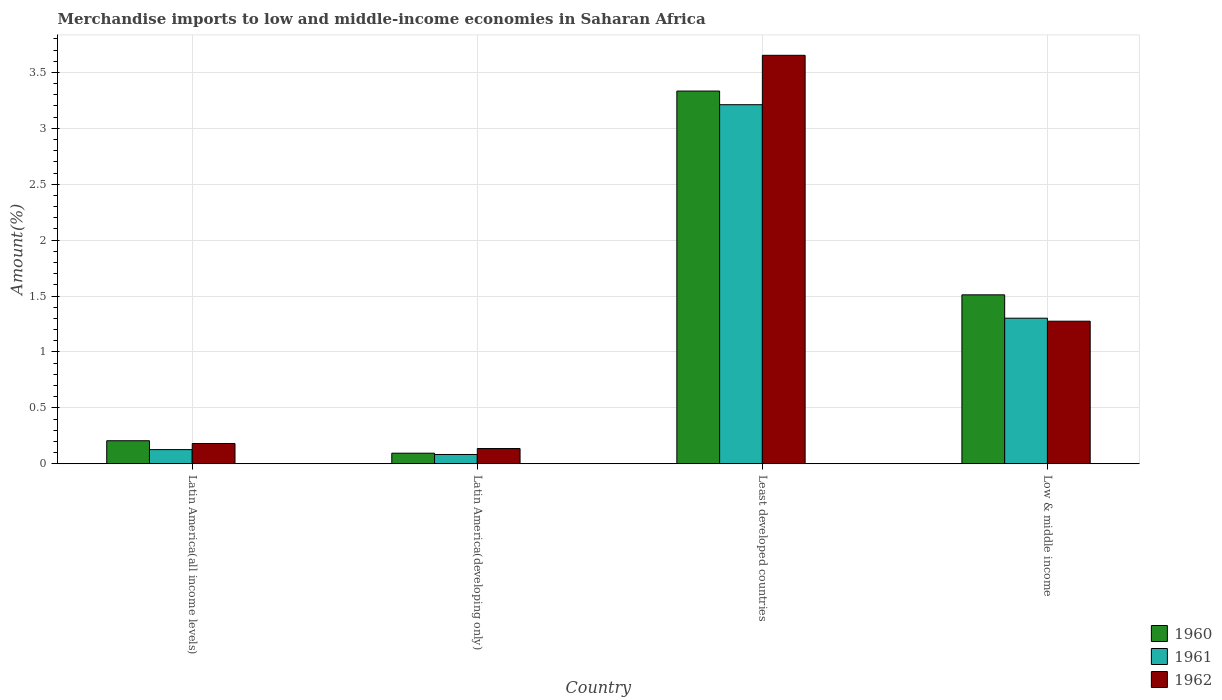How many different coloured bars are there?
Make the answer very short. 3. Are the number of bars per tick equal to the number of legend labels?
Offer a terse response. Yes. Are the number of bars on each tick of the X-axis equal?
Your response must be concise. Yes. How many bars are there on the 3rd tick from the right?
Offer a terse response. 3. What is the label of the 4th group of bars from the left?
Your answer should be compact. Low & middle income. In how many cases, is the number of bars for a given country not equal to the number of legend labels?
Provide a succinct answer. 0. What is the percentage of amount earned from merchandise imports in 1961 in Latin America(developing only)?
Keep it short and to the point. 0.08. Across all countries, what is the maximum percentage of amount earned from merchandise imports in 1961?
Your answer should be compact. 3.21. Across all countries, what is the minimum percentage of amount earned from merchandise imports in 1960?
Offer a very short reply. 0.09. In which country was the percentage of amount earned from merchandise imports in 1960 maximum?
Provide a succinct answer. Least developed countries. In which country was the percentage of amount earned from merchandise imports in 1962 minimum?
Your answer should be compact. Latin America(developing only). What is the total percentage of amount earned from merchandise imports in 1962 in the graph?
Give a very brief answer. 5.24. What is the difference between the percentage of amount earned from merchandise imports in 1961 in Latin America(all income levels) and that in Low & middle income?
Ensure brevity in your answer.  -1.18. What is the difference between the percentage of amount earned from merchandise imports in 1962 in Least developed countries and the percentage of amount earned from merchandise imports in 1961 in Latin America(developing only)?
Your response must be concise. 3.57. What is the average percentage of amount earned from merchandise imports in 1962 per country?
Your answer should be compact. 1.31. What is the difference between the percentage of amount earned from merchandise imports of/in 1960 and percentage of amount earned from merchandise imports of/in 1962 in Least developed countries?
Your answer should be very brief. -0.32. In how many countries, is the percentage of amount earned from merchandise imports in 1962 greater than 3.3 %?
Your answer should be compact. 1. What is the ratio of the percentage of amount earned from merchandise imports in 1962 in Latin America(developing only) to that in Least developed countries?
Give a very brief answer. 0.04. Is the percentage of amount earned from merchandise imports in 1961 in Least developed countries less than that in Low & middle income?
Provide a short and direct response. No. What is the difference between the highest and the second highest percentage of amount earned from merchandise imports in 1960?
Keep it short and to the point. -1.3. What is the difference between the highest and the lowest percentage of amount earned from merchandise imports in 1961?
Offer a terse response. 3.13. Is the sum of the percentage of amount earned from merchandise imports in 1961 in Latin America(developing only) and Least developed countries greater than the maximum percentage of amount earned from merchandise imports in 1960 across all countries?
Your answer should be compact. No. What does the 3rd bar from the left in Latin America(all income levels) represents?
Offer a terse response. 1962. What does the 1st bar from the right in Low & middle income represents?
Provide a short and direct response. 1962. Is it the case that in every country, the sum of the percentage of amount earned from merchandise imports in 1961 and percentage of amount earned from merchandise imports in 1960 is greater than the percentage of amount earned from merchandise imports in 1962?
Keep it short and to the point. Yes. How many bars are there?
Give a very brief answer. 12. Are all the bars in the graph horizontal?
Ensure brevity in your answer.  No. What is the difference between two consecutive major ticks on the Y-axis?
Give a very brief answer. 0.5. Does the graph contain any zero values?
Give a very brief answer. No. Where does the legend appear in the graph?
Offer a very short reply. Bottom right. How many legend labels are there?
Make the answer very short. 3. What is the title of the graph?
Your answer should be compact. Merchandise imports to low and middle-income economies in Saharan Africa. What is the label or title of the X-axis?
Make the answer very short. Country. What is the label or title of the Y-axis?
Make the answer very short. Amount(%). What is the Amount(%) of 1960 in Latin America(all income levels)?
Keep it short and to the point. 0.21. What is the Amount(%) in 1961 in Latin America(all income levels)?
Give a very brief answer. 0.13. What is the Amount(%) of 1962 in Latin America(all income levels)?
Your answer should be very brief. 0.18. What is the Amount(%) in 1960 in Latin America(developing only)?
Your response must be concise. 0.09. What is the Amount(%) in 1961 in Latin America(developing only)?
Keep it short and to the point. 0.08. What is the Amount(%) in 1962 in Latin America(developing only)?
Make the answer very short. 0.14. What is the Amount(%) of 1960 in Least developed countries?
Offer a terse response. 3.33. What is the Amount(%) in 1961 in Least developed countries?
Make the answer very short. 3.21. What is the Amount(%) of 1962 in Least developed countries?
Provide a short and direct response. 3.65. What is the Amount(%) in 1960 in Low & middle income?
Offer a terse response. 1.51. What is the Amount(%) of 1961 in Low & middle income?
Provide a short and direct response. 1.3. What is the Amount(%) of 1962 in Low & middle income?
Give a very brief answer. 1.27. Across all countries, what is the maximum Amount(%) in 1960?
Your response must be concise. 3.33. Across all countries, what is the maximum Amount(%) of 1961?
Your answer should be very brief. 3.21. Across all countries, what is the maximum Amount(%) in 1962?
Your answer should be compact. 3.65. Across all countries, what is the minimum Amount(%) in 1960?
Keep it short and to the point. 0.09. Across all countries, what is the minimum Amount(%) in 1961?
Give a very brief answer. 0.08. Across all countries, what is the minimum Amount(%) of 1962?
Keep it short and to the point. 0.14. What is the total Amount(%) of 1960 in the graph?
Your answer should be compact. 5.14. What is the total Amount(%) in 1961 in the graph?
Make the answer very short. 4.72. What is the total Amount(%) of 1962 in the graph?
Your response must be concise. 5.24. What is the difference between the Amount(%) of 1960 in Latin America(all income levels) and that in Latin America(developing only)?
Offer a terse response. 0.11. What is the difference between the Amount(%) of 1961 in Latin America(all income levels) and that in Latin America(developing only)?
Provide a short and direct response. 0.04. What is the difference between the Amount(%) in 1962 in Latin America(all income levels) and that in Latin America(developing only)?
Offer a terse response. 0.05. What is the difference between the Amount(%) of 1960 in Latin America(all income levels) and that in Least developed countries?
Provide a succinct answer. -3.13. What is the difference between the Amount(%) of 1961 in Latin America(all income levels) and that in Least developed countries?
Offer a very short reply. -3.08. What is the difference between the Amount(%) in 1962 in Latin America(all income levels) and that in Least developed countries?
Your response must be concise. -3.47. What is the difference between the Amount(%) in 1960 in Latin America(all income levels) and that in Low & middle income?
Make the answer very short. -1.3. What is the difference between the Amount(%) in 1961 in Latin America(all income levels) and that in Low & middle income?
Ensure brevity in your answer.  -1.18. What is the difference between the Amount(%) of 1962 in Latin America(all income levels) and that in Low & middle income?
Offer a very short reply. -1.09. What is the difference between the Amount(%) of 1960 in Latin America(developing only) and that in Least developed countries?
Your answer should be compact. -3.24. What is the difference between the Amount(%) of 1961 in Latin America(developing only) and that in Least developed countries?
Give a very brief answer. -3.13. What is the difference between the Amount(%) of 1962 in Latin America(developing only) and that in Least developed countries?
Offer a very short reply. -3.52. What is the difference between the Amount(%) in 1960 in Latin America(developing only) and that in Low & middle income?
Keep it short and to the point. -1.42. What is the difference between the Amount(%) in 1961 in Latin America(developing only) and that in Low & middle income?
Your answer should be compact. -1.22. What is the difference between the Amount(%) of 1962 in Latin America(developing only) and that in Low & middle income?
Give a very brief answer. -1.14. What is the difference between the Amount(%) of 1960 in Least developed countries and that in Low & middle income?
Ensure brevity in your answer.  1.82. What is the difference between the Amount(%) of 1961 in Least developed countries and that in Low & middle income?
Make the answer very short. 1.91. What is the difference between the Amount(%) of 1962 in Least developed countries and that in Low & middle income?
Provide a short and direct response. 2.38. What is the difference between the Amount(%) of 1960 in Latin America(all income levels) and the Amount(%) of 1961 in Latin America(developing only)?
Provide a short and direct response. 0.12. What is the difference between the Amount(%) in 1960 in Latin America(all income levels) and the Amount(%) in 1962 in Latin America(developing only)?
Offer a terse response. 0.07. What is the difference between the Amount(%) in 1961 in Latin America(all income levels) and the Amount(%) in 1962 in Latin America(developing only)?
Give a very brief answer. -0.01. What is the difference between the Amount(%) in 1960 in Latin America(all income levels) and the Amount(%) in 1961 in Least developed countries?
Your answer should be very brief. -3.01. What is the difference between the Amount(%) of 1960 in Latin America(all income levels) and the Amount(%) of 1962 in Least developed countries?
Your answer should be very brief. -3.45. What is the difference between the Amount(%) of 1961 in Latin America(all income levels) and the Amount(%) of 1962 in Least developed countries?
Ensure brevity in your answer.  -3.53. What is the difference between the Amount(%) of 1960 in Latin America(all income levels) and the Amount(%) of 1961 in Low & middle income?
Provide a short and direct response. -1.1. What is the difference between the Amount(%) in 1960 in Latin America(all income levels) and the Amount(%) in 1962 in Low & middle income?
Offer a very short reply. -1.07. What is the difference between the Amount(%) in 1961 in Latin America(all income levels) and the Amount(%) in 1962 in Low & middle income?
Provide a short and direct response. -1.15. What is the difference between the Amount(%) in 1960 in Latin America(developing only) and the Amount(%) in 1961 in Least developed countries?
Offer a very short reply. -3.12. What is the difference between the Amount(%) of 1960 in Latin America(developing only) and the Amount(%) of 1962 in Least developed countries?
Give a very brief answer. -3.56. What is the difference between the Amount(%) of 1961 in Latin America(developing only) and the Amount(%) of 1962 in Least developed countries?
Your answer should be compact. -3.57. What is the difference between the Amount(%) in 1960 in Latin America(developing only) and the Amount(%) in 1961 in Low & middle income?
Your response must be concise. -1.21. What is the difference between the Amount(%) in 1960 in Latin America(developing only) and the Amount(%) in 1962 in Low & middle income?
Provide a short and direct response. -1.18. What is the difference between the Amount(%) of 1961 in Latin America(developing only) and the Amount(%) of 1962 in Low & middle income?
Give a very brief answer. -1.19. What is the difference between the Amount(%) in 1960 in Least developed countries and the Amount(%) in 1961 in Low & middle income?
Ensure brevity in your answer.  2.03. What is the difference between the Amount(%) of 1960 in Least developed countries and the Amount(%) of 1962 in Low & middle income?
Keep it short and to the point. 2.06. What is the difference between the Amount(%) of 1961 in Least developed countries and the Amount(%) of 1962 in Low & middle income?
Make the answer very short. 1.94. What is the average Amount(%) in 1960 per country?
Give a very brief answer. 1.29. What is the average Amount(%) of 1961 per country?
Make the answer very short. 1.18. What is the average Amount(%) in 1962 per country?
Provide a succinct answer. 1.31. What is the difference between the Amount(%) of 1960 and Amount(%) of 1961 in Latin America(all income levels)?
Make the answer very short. 0.08. What is the difference between the Amount(%) of 1960 and Amount(%) of 1962 in Latin America(all income levels)?
Your response must be concise. 0.02. What is the difference between the Amount(%) of 1961 and Amount(%) of 1962 in Latin America(all income levels)?
Ensure brevity in your answer.  -0.05. What is the difference between the Amount(%) of 1960 and Amount(%) of 1961 in Latin America(developing only)?
Your response must be concise. 0.01. What is the difference between the Amount(%) of 1960 and Amount(%) of 1962 in Latin America(developing only)?
Provide a short and direct response. -0.04. What is the difference between the Amount(%) of 1961 and Amount(%) of 1962 in Latin America(developing only)?
Give a very brief answer. -0.05. What is the difference between the Amount(%) in 1960 and Amount(%) in 1961 in Least developed countries?
Make the answer very short. 0.12. What is the difference between the Amount(%) in 1960 and Amount(%) in 1962 in Least developed countries?
Give a very brief answer. -0.32. What is the difference between the Amount(%) of 1961 and Amount(%) of 1962 in Least developed countries?
Your answer should be compact. -0.44. What is the difference between the Amount(%) of 1960 and Amount(%) of 1961 in Low & middle income?
Offer a very short reply. 0.21. What is the difference between the Amount(%) in 1960 and Amount(%) in 1962 in Low & middle income?
Offer a terse response. 0.24. What is the difference between the Amount(%) in 1961 and Amount(%) in 1962 in Low & middle income?
Your answer should be compact. 0.03. What is the ratio of the Amount(%) of 1960 in Latin America(all income levels) to that in Latin America(developing only)?
Make the answer very short. 2.18. What is the ratio of the Amount(%) of 1961 in Latin America(all income levels) to that in Latin America(developing only)?
Give a very brief answer. 1.53. What is the ratio of the Amount(%) in 1962 in Latin America(all income levels) to that in Latin America(developing only)?
Offer a very short reply. 1.33. What is the ratio of the Amount(%) in 1960 in Latin America(all income levels) to that in Least developed countries?
Ensure brevity in your answer.  0.06. What is the ratio of the Amount(%) of 1961 in Latin America(all income levels) to that in Least developed countries?
Provide a succinct answer. 0.04. What is the ratio of the Amount(%) of 1962 in Latin America(all income levels) to that in Least developed countries?
Offer a terse response. 0.05. What is the ratio of the Amount(%) of 1960 in Latin America(all income levels) to that in Low & middle income?
Your answer should be very brief. 0.14. What is the ratio of the Amount(%) in 1961 in Latin America(all income levels) to that in Low & middle income?
Give a very brief answer. 0.1. What is the ratio of the Amount(%) in 1962 in Latin America(all income levels) to that in Low & middle income?
Your answer should be very brief. 0.14. What is the ratio of the Amount(%) of 1960 in Latin America(developing only) to that in Least developed countries?
Provide a succinct answer. 0.03. What is the ratio of the Amount(%) in 1961 in Latin America(developing only) to that in Least developed countries?
Your answer should be very brief. 0.03. What is the ratio of the Amount(%) in 1962 in Latin America(developing only) to that in Least developed countries?
Your answer should be compact. 0.04. What is the ratio of the Amount(%) in 1960 in Latin America(developing only) to that in Low & middle income?
Your answer should be compact. 0.06. What is the ratio of the Amount(%) in 1961 in Latin America(developing only) to that in Low & middle income?
Your answer should be very brief. 0.06. What is the ratio of the Amount(%) of 1962 in Latin America(developing only) to that in Low & middle income?
Provide a short and direct response. 0.11. What is the ratio of the Amount(%) in 1960 in Least developed countries to that in Low & middle income?
Make the answer very short. 2.21. What is the ratio of the Amount(%) of 1961 in Least developed countries to that in Low & middle income?
Your response must be concise. 2.47. What is the ratio of the Amount(%) of 1962 in Least developed countries to that in Low & middle income?
Provide a succinct answer. 2.87. What is the difference between the highest and the second highest Amount(%) of 1960?
Offer a terse response. 1.82. What is the difference between the highest and the second highest Amount(%) of 1961?
Offer a very short reply. 1.91. What is the difference between the highest and the second highest Amount(%) of 1962?
Make the answer very short. 2.38. What is the difference between the highest and the lowest Amount(%) of 1960?
Give a very brief answer. 3.24. What is the difference between the highest and the lowest Amount(%) of 1961?
Make the answer very short. 3.13. What is the difference between the highest and the lowest Amount(%) of 1962?
Your answer should be compact. 3.52. 